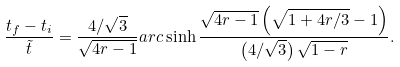<formula> <loc_0><loc_0><loc_500><loc_500>\frac { t _ { f } - t _ { i } } { \tilde { t } } = \frac { 4 / \sqrt { 3 } } { \sqrt { 4 r - 1 } } a r c \sinh \frac { \sqrt { 4 r - 1 } \left ( \sqrt { 1 + 4 r / 3 } - 1 \right ) } { \left ( 4 / \sqrt { 3 } \right ) \sqrt { 1 - r } } .</formula> 